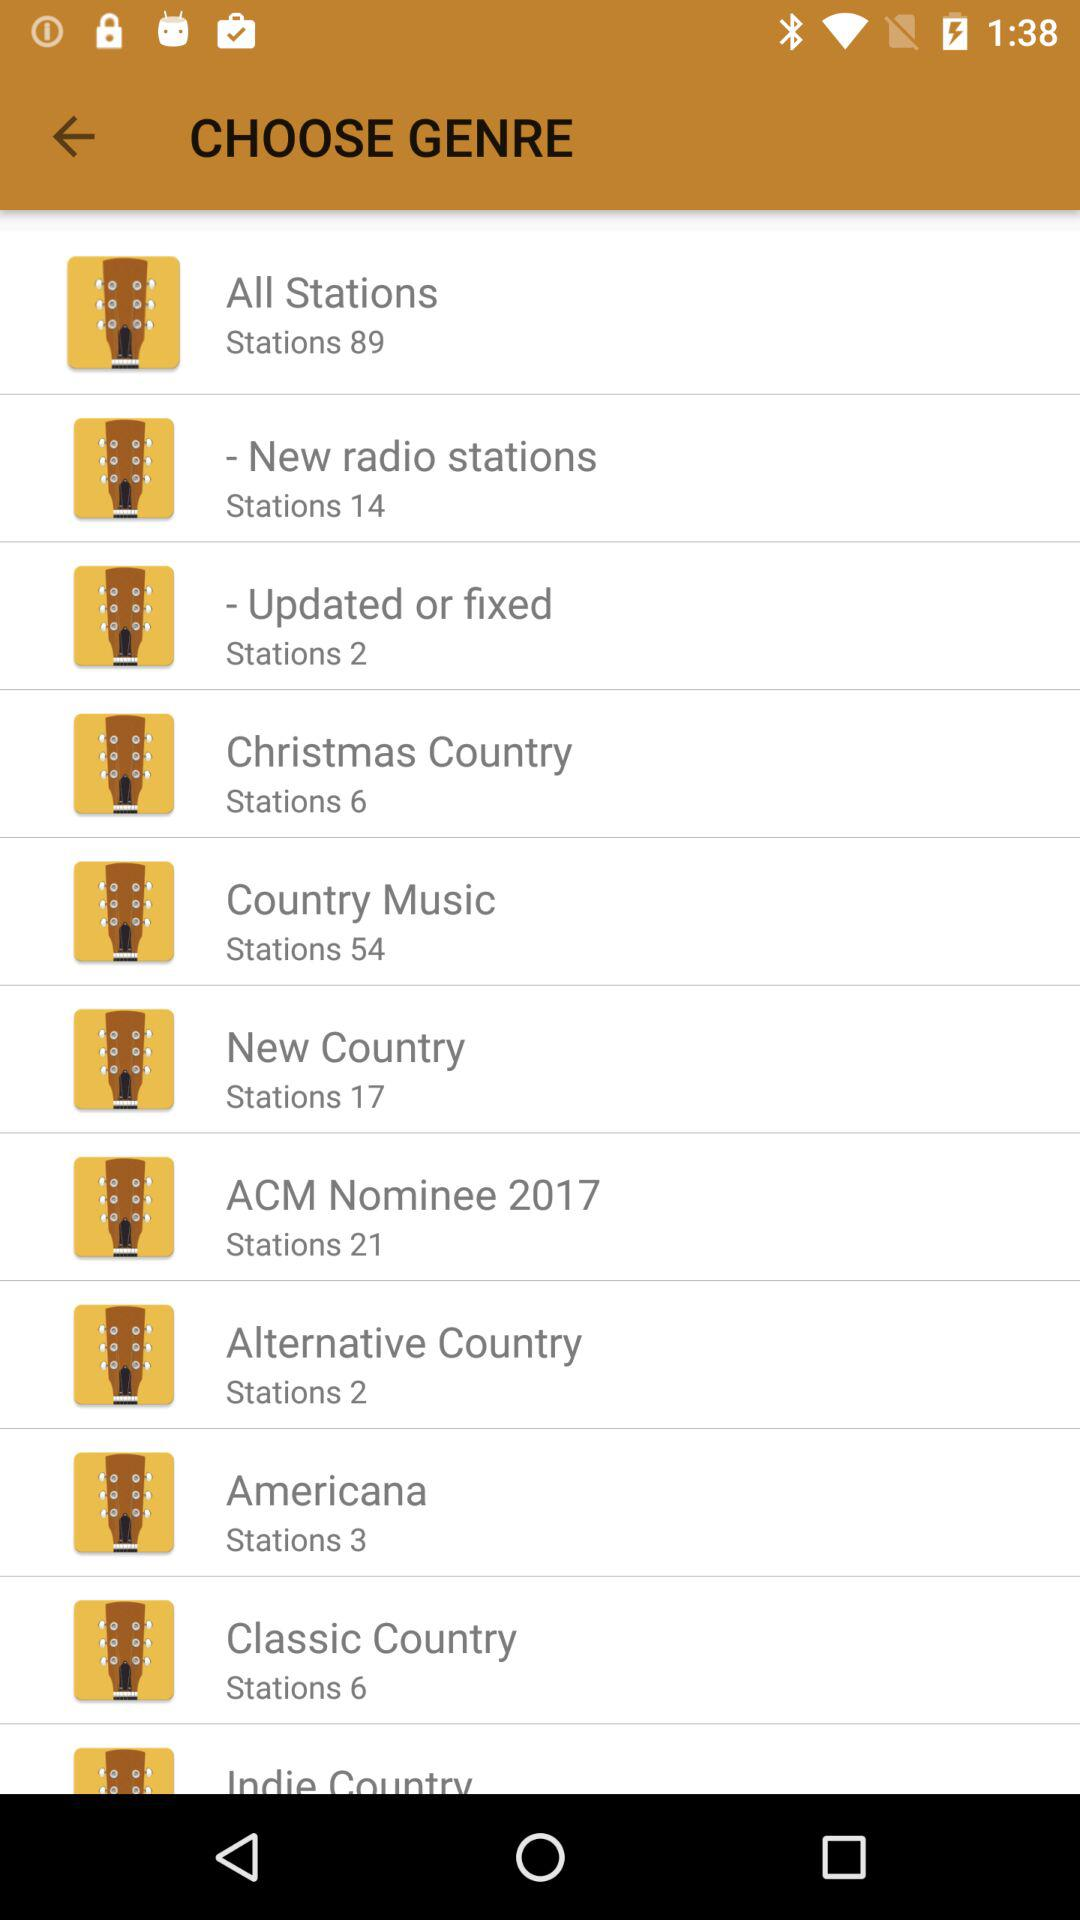How many more stations are there in the 'All Stations' category than in the 'New Country' category?
Answer the question using a single word or phrase. 72 